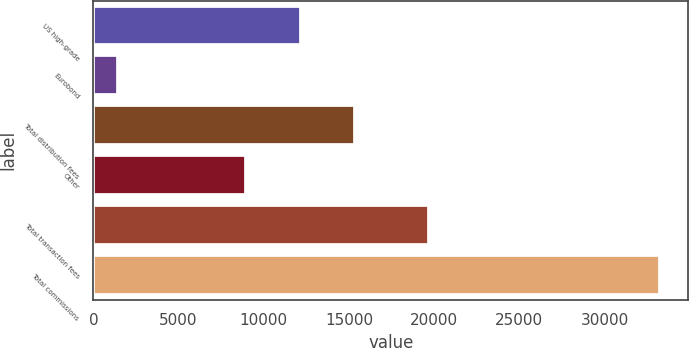Convert chart to OTSL. <chart><loc_0><loc_0><loc_500><loc_500><bar_chart><fcel>US high-grade<fcel>Eurobond<fcel>Total distribution fees<fcel>Other<fcel>Total transaction fees<fcel>Total commissions<nl><fcel>12166.8<fcel>1456<fcel>15347.6<fcel>8986<fcel>19695<fcel>33264<nl></chart> 